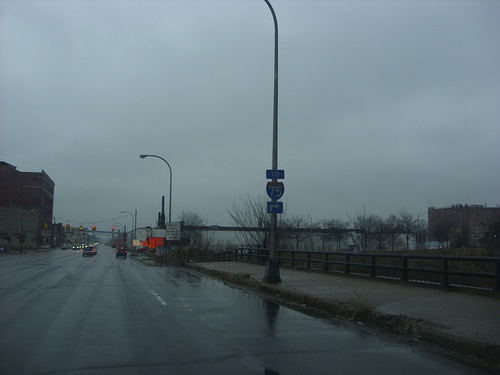Describe the objects in this image and their specific colors. I can see car in darkgray, black, maroon, and brown tones, car in darkgray, black, darkblue, and maroon tones, car in darkgray, black, gray, and purple tones, car in darkgray, black, gray, and darkblue tones, and car in darkgray, black, and purple tones in this image. 